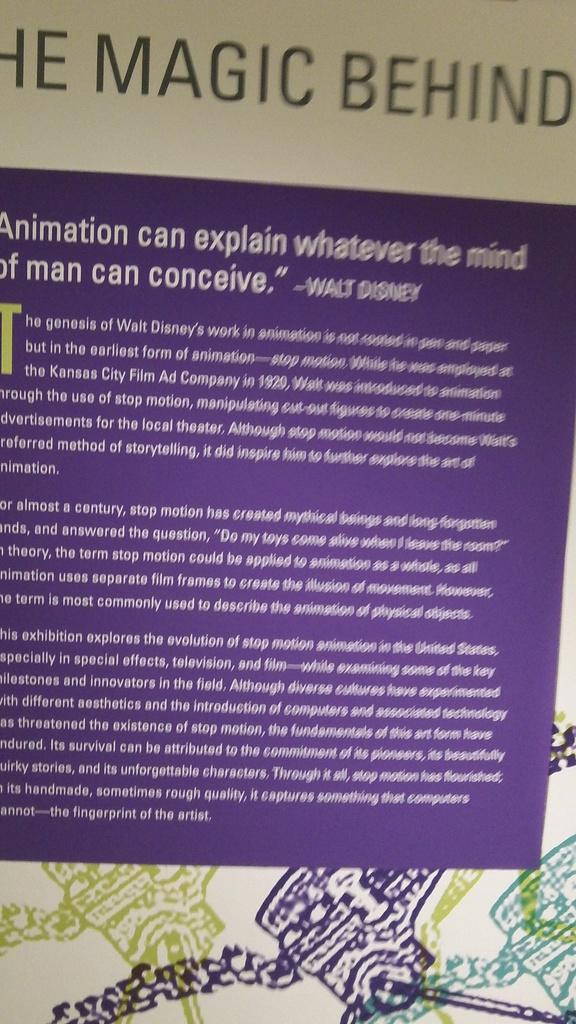<image>
Share a concise interpretation of the image provided. A poster explaining the history of animation at Disney. 